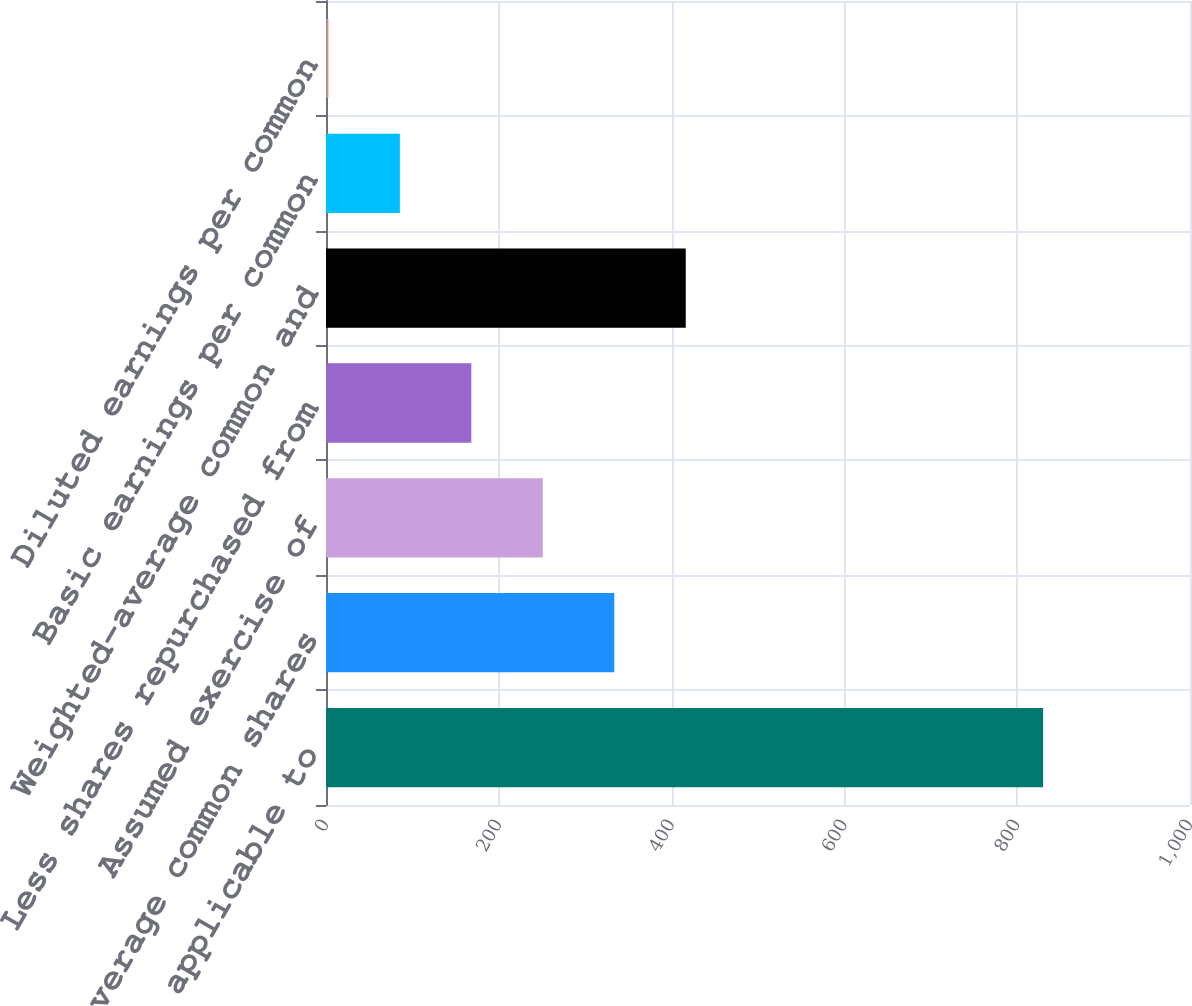<chart> <loc_0><loc_0><loc_500><loc_500><bar_chart><fcel>Net income applicable to<fcel>Weighted-average common shares<fcel>Assumed exercise of<fcel>Less shares repurchased from<fcel>Weighted-average common and<fcel>Basic earnings per common<fcel>Diluted earnings per common<nl><fcel>830<fcel>333.66<fcel>250.93<fcel>168.2<fcel>416.39<fcel>85.47<fcel>2.74<nl></chart> 